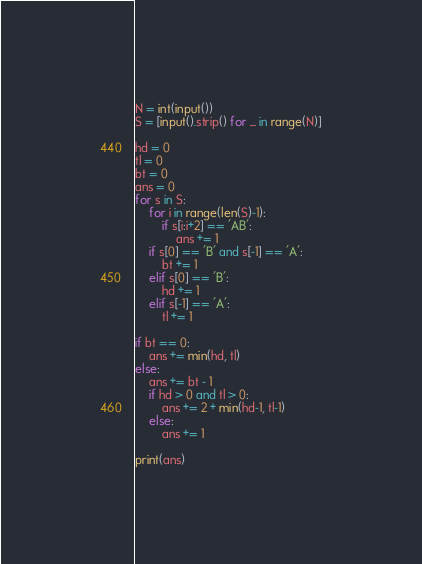Convert code to text. <code><loc_0><loc_0><loc_500><loc_500><_Python_>N = int(input())
S = [input().strip() for _ in range(N)]

hd = 0
tl = 0
bt = 0
ans = 0
for s in S:
    for i in range(len(S)-1):
        if s[i:i+2] == 'AB':
            ans += 1
    if s[0] == 'B' and s[-1] == 'A':
        bt += 1
    elif s[0] == 'B':
        hd += 1
    elif s[-1] == 'A':
        tl += 1

if bt == 0:
    ans += min(hd, tl)
else:
    ans += bt - 1
    if hd > 0 and tl > 0:
        ans += 2 + min(hd-1, tl-1)
    else:
        ans += 1

print(ans)
</code> 